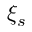<formula> <loc_0><loc_0><loc_500><loc_500>\xi _ { s }</formula> 